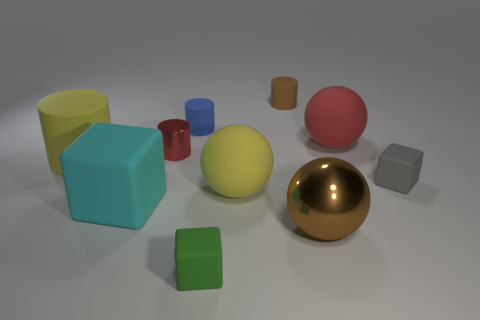There is a object that is the same color as the shiny ball; what size is it?
Make the answer very short. Small. There is a matte thing that is both to the left of the tiny gray thing and to the right of the small brown matte thing; what is its size?
Your response must be concise. Large. What number of other things have the same shape as the small blue rubber thing?
Give a very brief answer. 3. What is the large cyan object made of?
Your answer should be compact. Rubber. Do the small brown object and the small red metallic thing have the same shape?
Provide a succinct answer. Yes. Is there a cube made of the same material as the blue cylinder?
Your answer should be compact. Yes. There is a rubber cube that is on the left side of the brown shiny object and behind the large metallic ball; what is its color?
Offer a terse response. Cyan. What is the tiny cylinder behind the blue rubber cylinder made of?
Ensure brevity in your answer.  Rubber. Are there any other tiny gray matte things of the same shape as the small gray thing?
Your answer should be very brief. No. What number of other things are the same shape as the brown rubber thing?
Provide a short and direct response. 3. 